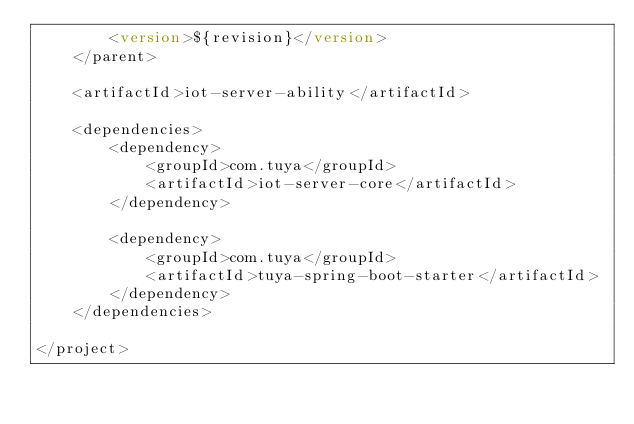Convert code to text. <code><loc_0><loc_0><loc_500><loc_500><_XML_>        <version>${revision}</version>
    </parent>

    <artifactId>iot-server-ability</artifactId>

    <dependencies>
        <dependency>
            <groupId>com.tuya</groupId>
            <artifactId>iot-server-core</artifactId>
        </dependency>

        <dependency>
            <groupId>com.tuya</groupId>
            <artifactId>tuya-spring-boot-starter</artifactId>
        </dependency>
    </dependencies>

</project>
</code> 